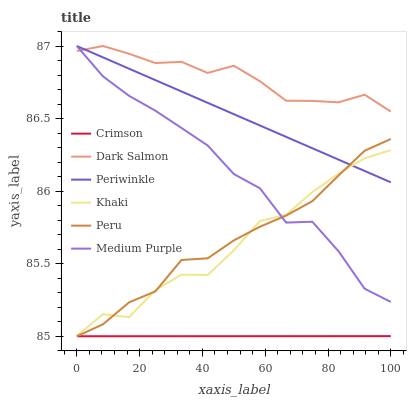Does Crimson have the minimum area under the curve?
Answer yes or no. Yes. Does Dark Salmon have the maximum area under the curve?
Answer yes or no. Yes. Does Medium Purple have the minimum area under the curve?
Answer yes or no. No. Does Medium Purple have the maximum area under the curve?
Answer yes or no. No. Is Periwinkle the smoothest?
Answer yes or no. Yes. Is Khaki the roughest?
Answer yes or no. Yes. Is Dark Salmon the smoothest?
Answer yes or no. No. Is Dark Salmon the roughest?
Answer yes or no. No. Does Peru have the lowest value?
Answer yes or no. Yes. Does Medium Purple have the lowest value?
Answer yes or no. No. Does Periwinkle have the highest value?
Answer yes or no. Yes. Does Peru have the highest value?
Answer yes or no. No. Is Crimson less than Periwinkle?
Answer yes or no. Yes. Is Periwinkle greater than Crimson?
Answer yes or no. Yes. Does Peru intersect Khaki?
Answer yes or no. Yes. Is Peru less than Khaki?
Answer yes or no. No. Is Peru greater than Khaki?
Answer yes or no. No. Does Crimson intersect Periwinkle?
Answer yes or no. No. 